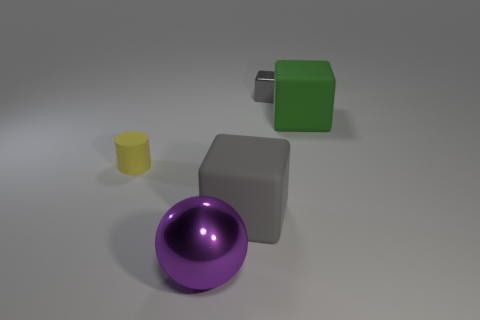There is a matte thing that is the same color as the shiny cube; what is its shape?
Your answer should be compact. Cube. What number of big gray matte things are the same shape as the tiny gray metal object?
Make the answer very short. 1. The other cube that is made of the same material as the big green block is what size?
Ensure brevity in your answer.  Large. Is the size of the purple thing the same as the green object?
Offer a terse response. Yes. Are there any brown cylinders?
Keep it short and to the point. No. What is the size of the rubber cube that is the same color as the tiny metal cube?
Your response must be concise. Large. There is a matte block that is in front of the small yellow rubber object that is on the left side of the cube that is right of the gray metal cube; what is its size?
Give a very brief answer. Large. How many tiny yellow cylinders have the same material as the small cube?
Ensure brevity in your answer.  0. How many green shiny balls are the same size as the green thing?
Your response must be concise. 0. The tiny object right of the metal object in front of the shiny thing behind the purple sphere is made of what material?
Keep it short and to the point. Metal. 